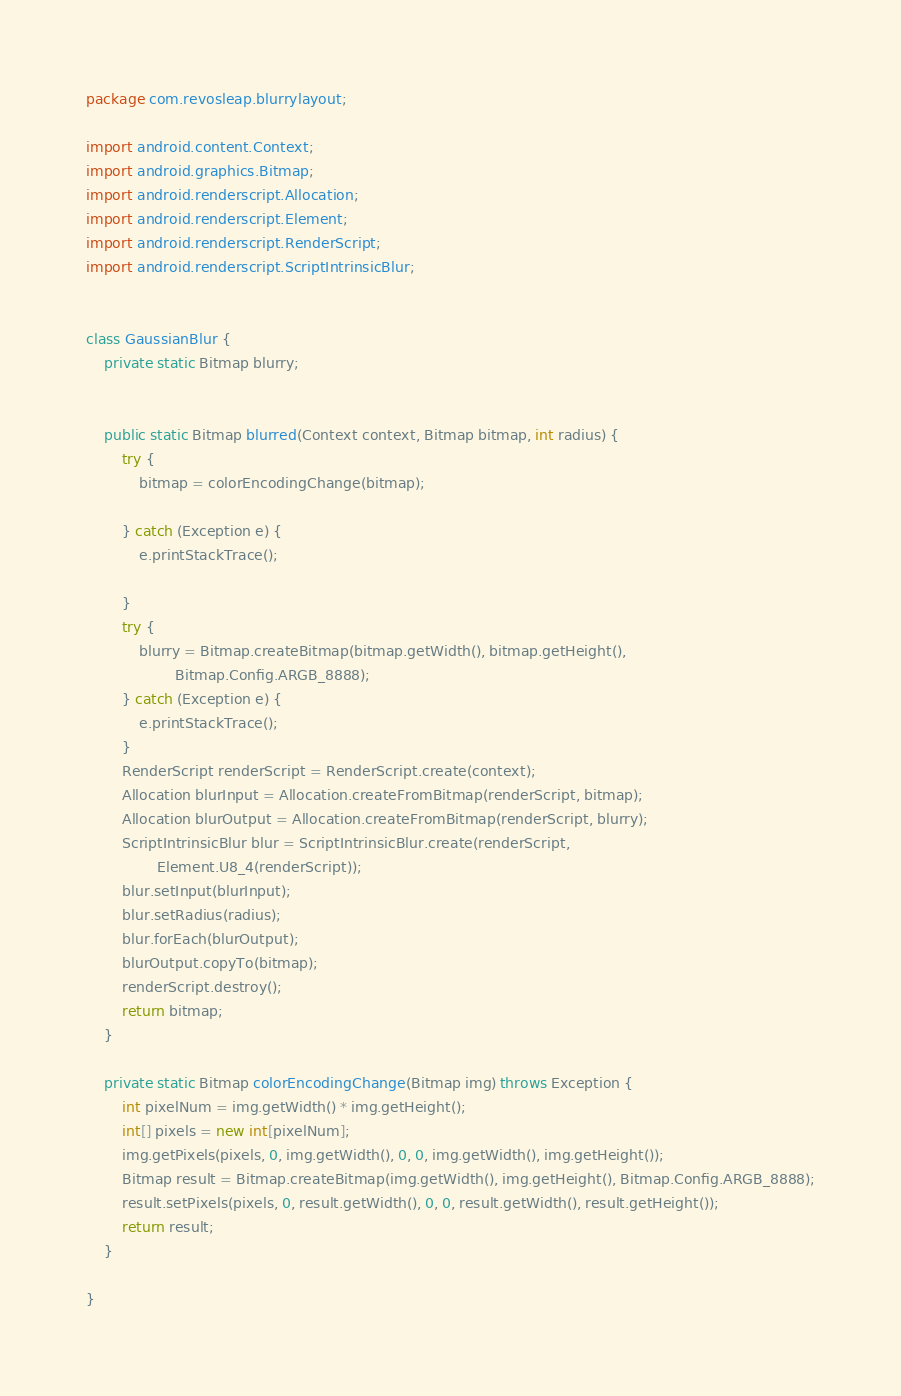<code> <loc_0><loc_0><loc_500><loc_500><_Java_>package com.revosleap.blurrylayout;

import android.content.Context;
import android.graphics.Bitmap;
import android.renderscript.Allocation;
import android.renderscript.Element;
import android.renderscript.RenderScript;
import android.renderscript.ScriptIntrinsicBlur;


class GaussianBlur {
    private static Bitmap blurry;


    public static Bitmap blurred(Context context, Bitmap bitmap, int radius) {
        try {
            bitmap = colorEncodingChange(bitmap);

        } catch (Exception e) {
            e.printStackTrace();

        }
        try {
            blurry = Bitmap.createBitmap(bitmap.getWidth(), bitmap.getHeight(),
                    Bitmap.Config.ARGB_8888);
        } catch (Exception e) {
            e.printStackTrace();
        }
        RenderScript renderScript = RenderScript.create(context);
        Allocation blurInput = Allocation.createFromBitmap(renderScript, bitmap);
        Allocation blurOutput = Allocation.createFromBitmap(renderScript, blurry);
        ScriptIntrinsicBlur blur = ScriptIntrinsicBlur.create(renderScript,
                Element.U8_4(renderScript));
        blur.setInput(blurInput);
        blur.setRadius(radius);
        blur.forEach(blurOutput);
        blurOutput.copyTo(bitmap);
        renderScript.destroy();
        return bitmap;
    }

    private static Bitmap colorEncodingChange(Bitmap img) throws Exception {
        int pixelNum = img.getWidth() * img.getHeight();
        int[] pixels = new int[pixelNum];
        img.getPixels(pixels, 0, img.getWidth(), 0, 0, img.getWidth(), img.getHeight());
        Bitmap result = Bitmap.createBitmap(img.getWidth(), img.getHeight(), Bitmap.Config.ARGB_8888);
        result.setPixels(pixels, 0, result.getWidth(), 0, 0, result.getWidth(), result.getHeight());
        return result;
    }

}
</code> 